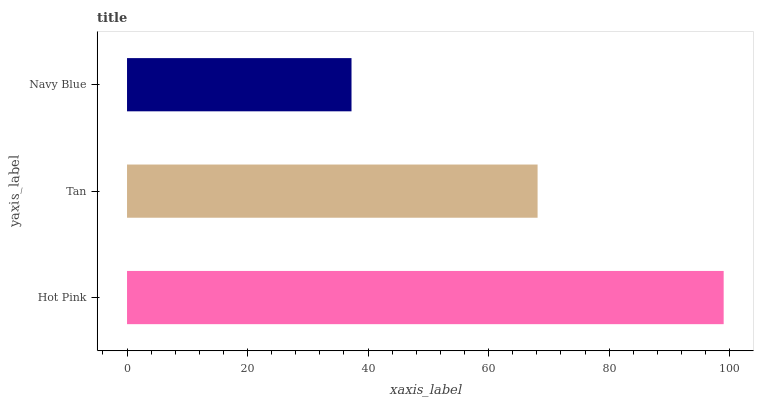Is Navy Blue the minimum?
Answer yes or no. Yes. Is Hot Pink the maximum?
Answer yes or no. Yes. Is Tan the minimum?
Answer yes or no. No. Is Tan the maximum?
Answer yes or no. No. Is Hot Pink greater than Tan?
Answer yes or no. Yes. Is Tan less than Hot Pink?
Answer yes or no. Yes. Is Tan greater than Hot Pink?
Answer yes or no. No. Is Hot Pink less than Tan?
Answer yes or no. No. Is Tan the high median?
Answer yes or no. Yes. Is Tan the low median?
Answer yes or no. Yes. Is Navy Blue the high median?
Answer yes or no. No. Is Hot Pink the low median?
Answer yes or no. No. 